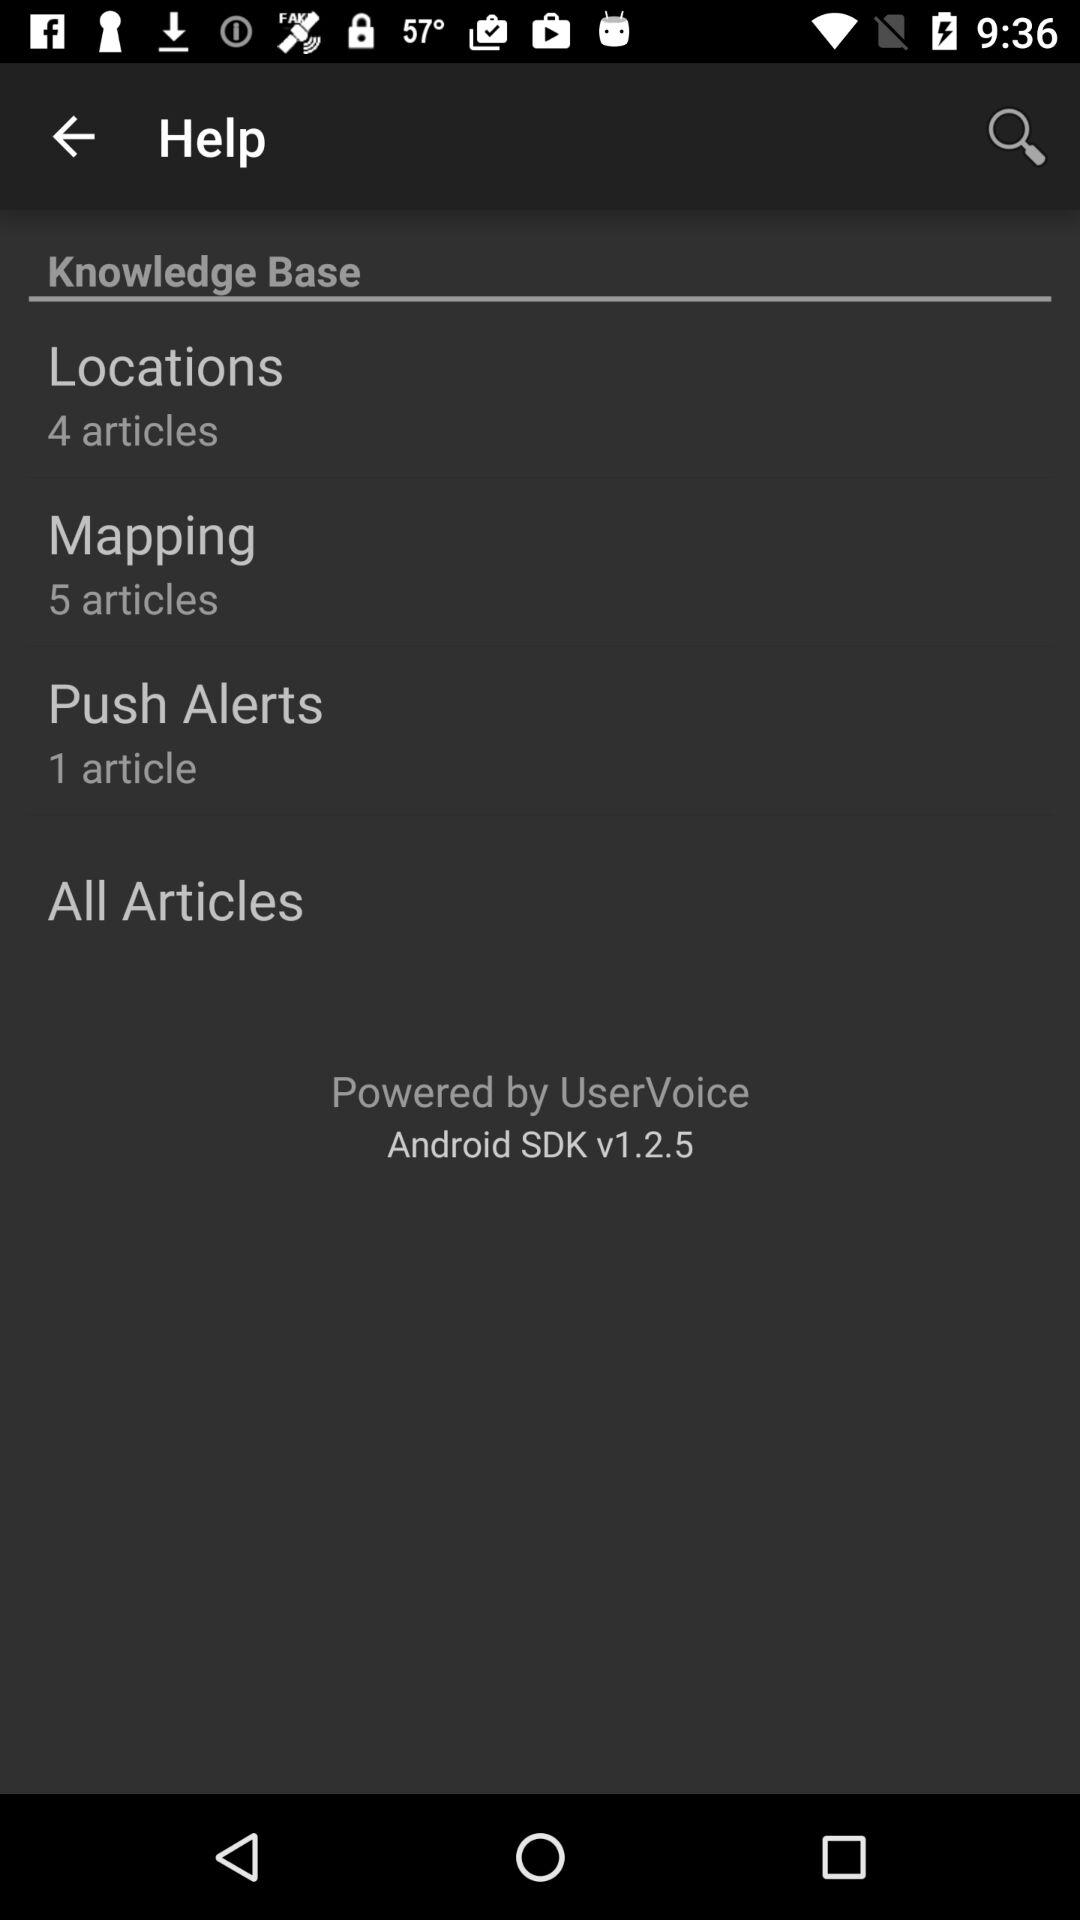What is the version? The version is Android SDK v1.2.5. 